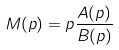<formula> <loc_0><loc_0><loc_500><loc_500>M ( p ) = p \frac { A ( p ) } { B ( p ) }</formula> 